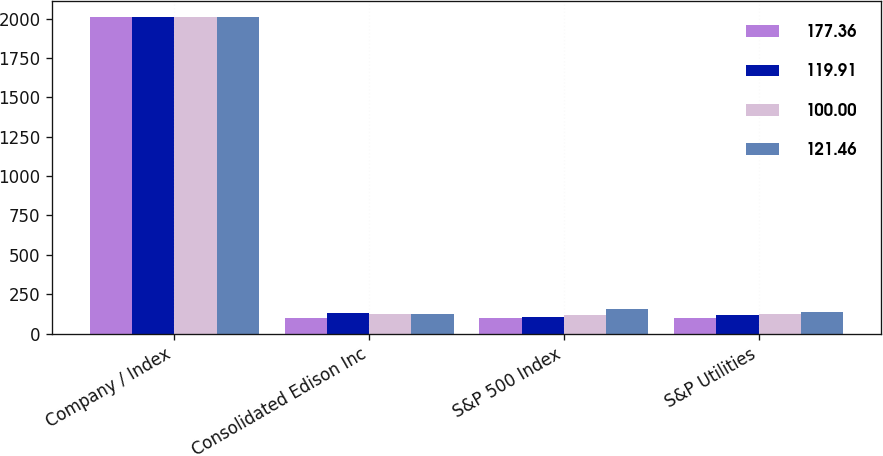Convert chart to OTSL. <chart><loc_0><loc_0><loc_500><loc_500><stacked_bar_chart><ecel><fcel>Company / Index<fcel>Consolidated Edison Inc<fcel>S&P 500 Index<fcel>S&P Utilities<nl><fcel>177.36<fcel>2010<fcel>100<fcel>100<fcel>100<nl><fcel>119.91<fcel>2011<fcel>130.82<fcel>102.11<fcel>119.91<nl><fcel>100<fcel>2012<fcel>122.02<fcel>118.45<fcel>121.46<nl><fcel>121.46<fcel>2013<fcel>126.65<fcel>156.82<fcel>137.51<nl></chart> 